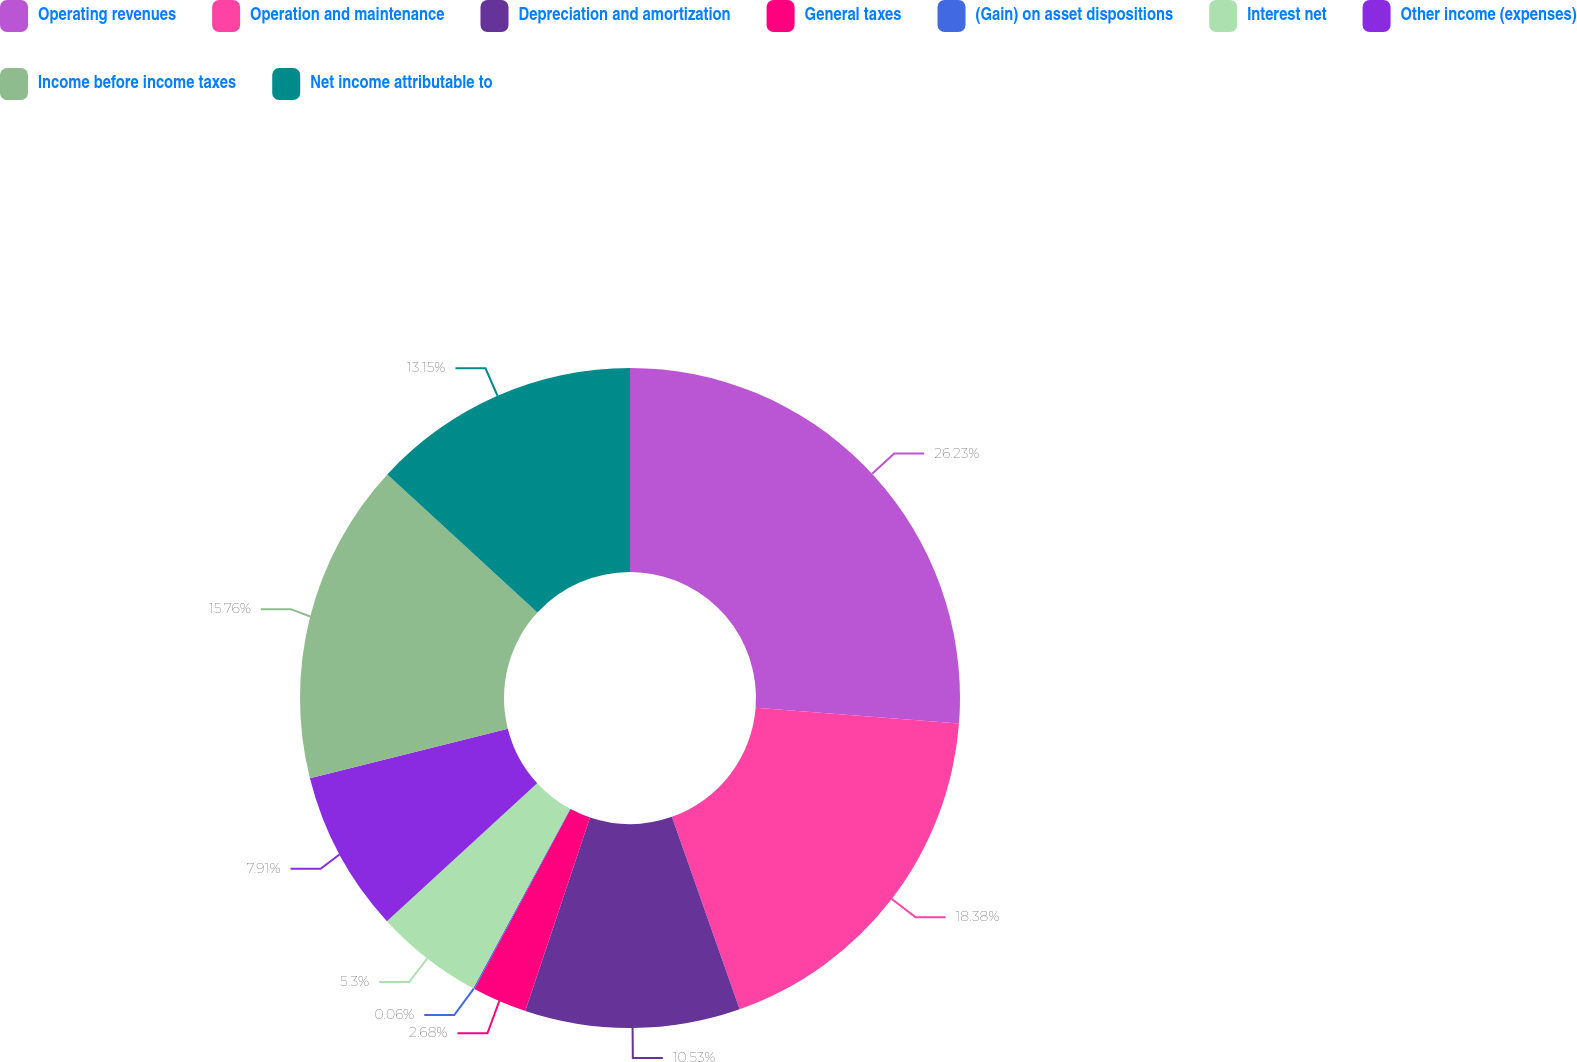Convert chart to OTSL. <chart><loc_0><loc_0><loc_500><loc_500><pie_chart><fcel>Operating revenues<fcel>Operation and maintenance<fcel>Depreciation and amortization<fcel>General taxes<fcel>(Gain) on asset dispositions<fcel>Interest net<fcel>Other income (expenses)<fcel>Income before income taxes<fcel>Net income attributable to<nl><fcel>26.23%<fcel>18.38%<fcel>10.53%<fcel>2.68%<fcel>0.06%<fcel>5.3%<fcel>7.91%<fcel>15.76%<fcel>13.15%<nl></chart> 